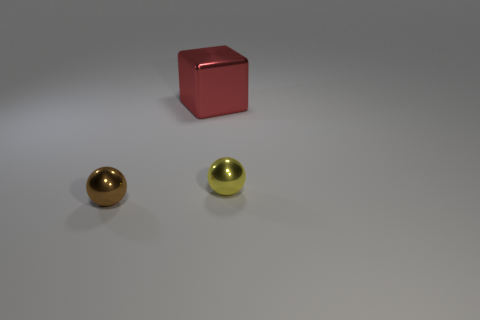Can you describe the lighting conditions in the scene? The lighting in the scene is subdued and appears to be coming from above the objects, casting a gentle shadow on the surface beneath them. It gives the impression of an indoor setting with artificial lighting, creating a soft contrast on the objects and a calm atmosphere. 